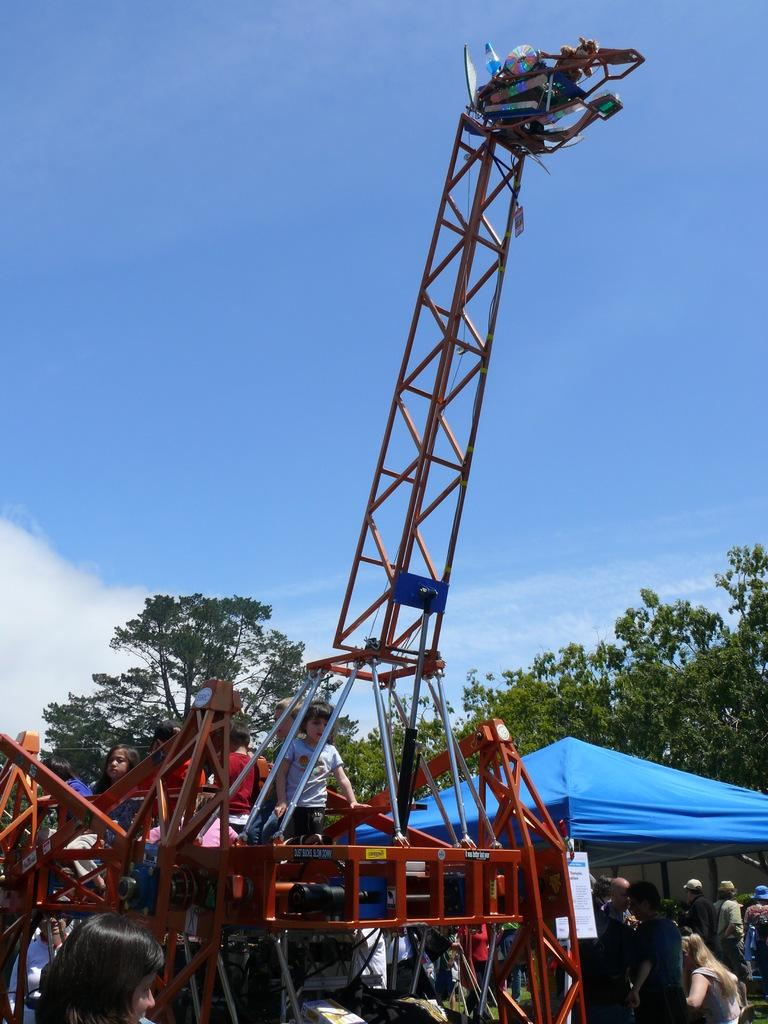What type of setting is depicted in the image? The image is an outdoor scene. What color is the sky in the image? The sky is blue in color. What can be seen in the distance in the image? There are trees in the distance, and they are green. What structure is present in the image? There is a tent in the image. How many people are visible in the image? Multiple people are standing under the tent. What else is present in the image besides the tent and people? There is a vehicle in the image, and some people are sitting on the vehicle. Can you tell me what type of tub the farmer is using in the image? There is no tub or farmer present in the image. What kind of guitar is being played by the person standing under the tent? There is no guitar or person playing a guitar in the image. 